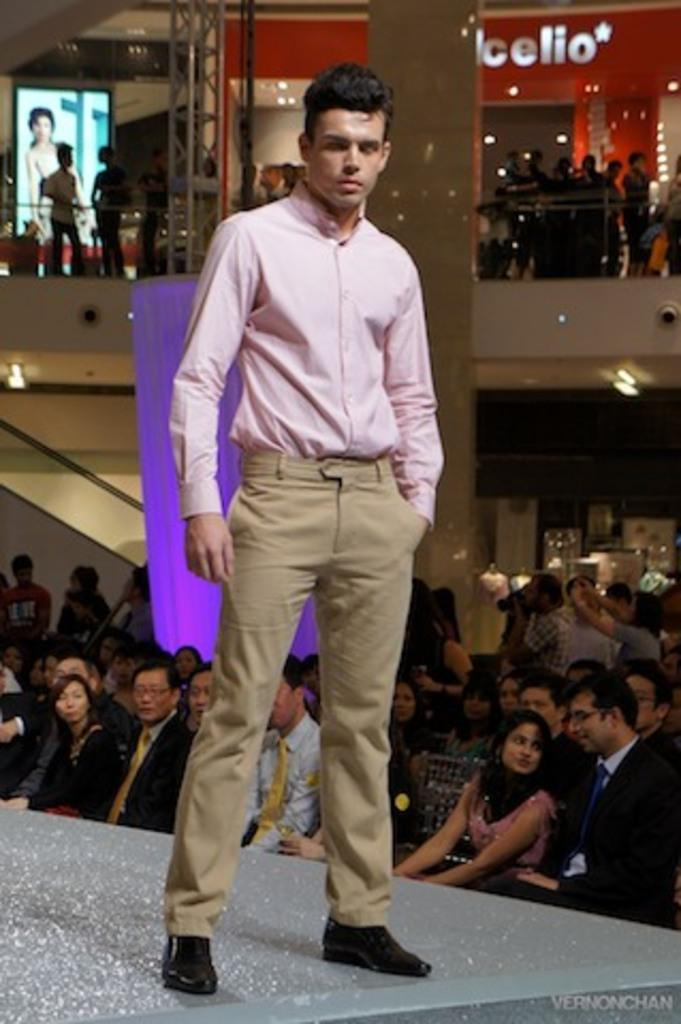What is the main subject of the image? There is a person standing in the center of the image. What can be seen in the background of the image? There is a wall, a screen, a banner, a pillar, a curtain, and lights in the background of the image. Are there any other people visible in the image? Yes, there is a group of people sitting in the background of the image. What type of growth can be observed in the image? There is no growth visible in the image; it is a static scene with people and objects. What organization is responsible for the event depicted in the image? The image does not provide any information about an event or an organization responsible for it. 